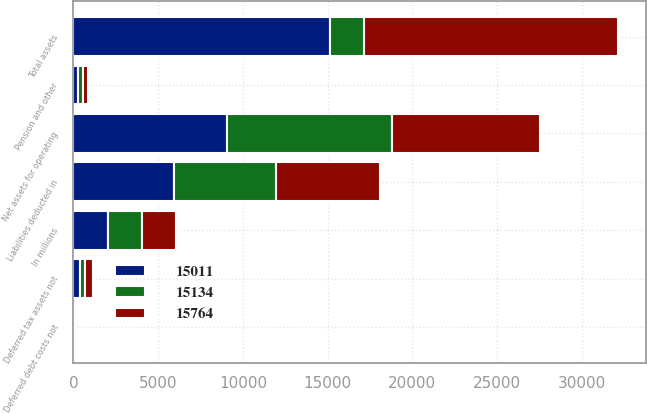Convert chart. <chart><loc_0><loc_0><loc_500><loc_500><stacked_bar_chart><ecel><fcel>In millions<fcel>Net assets for operating<fcel>Liabilities deducted in<fcel>Pension and other<fcel>Deferred tax assets not<fcel>Deferred debt costs not<fcel>Total assets<nl><fcel>15764<fcel>2016<fcel>8721<fcel>6152<fcel>284<fcel>420<fcel>2<fcel>15011<nl><fcel>15011<fcel>2015<fcel>9064<fcel>5920<fcel>242<fcel>390<fcel>2<fcel>15134<nl><fcel>15134<fcel>2014<fcel>9737<fcel>6009<fcel>319<fcel>314<fcel>23<fcel>2014.5<nl></chart> 